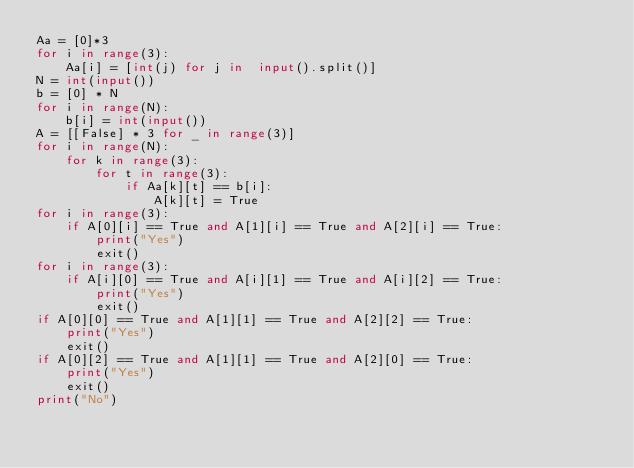<code> <loc_0><loc_0><loc_500><loc_500><_Python_>Aa = [0]*3
for i in range(3):
    Aa[i] = [int(j) for j in  input().split()]
N = int(input())
b = [0] * N
for i in range(N):
    b[i] = int(input())
A = [[False] * 3 for _ in range(3)]
for i in range(N):
    for k in range(3):
        for t in range(3):
            if Aa[k][t] == b[i]:
                A[k][t] = True
for i in range(3):
    if A[0][i] == True and A[1][i] == True and A[2][i] == True:
        print("Yes")
        exit()
for i in range(3):
    if A[i][0] == True and A[i][1] == True and A[i][2] == True:
        print("Yes")
        exit()
if A[0][0] == True and A[1][1] == True and A[2][2] == True:
    print("Yes")
    exit()
if A[0][2] == True and A[1][1] == True and A[2][0] == True:
    print("Yes")
    exit()
print("No")</code> 